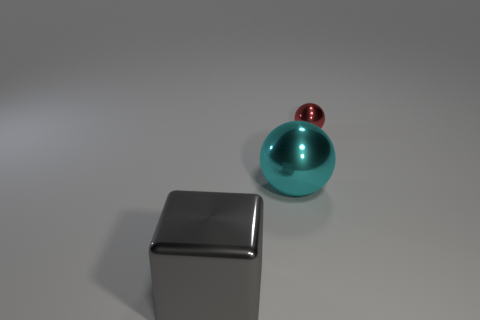What can you infer about the size of the objects? Based on their relative sizes and the perspective within the image, the cyan ball appears to be significantly larger than the red ball behind it. The box's edges provide additional context for scale, indicating that the cyan ball is perhaps similar in size to a basketball, while the red ball might be closer in size to a baseball. What does the arrangement of objects tell us? The arrangement of objects could suggest a deliberate placement for aesthetic composition or a visual demonstration of scale and perspective. The larger cyan ball's prominence in the foreground, alongside the smaller red ball and the box, creates a sense of depth and draws attention to the interplay of sizes and shapes. 